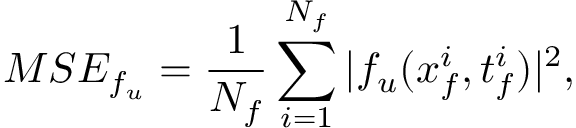<formula> <loc_0><loc_0><loc_500><loc_500>M S E _ { f _ { u } } = \frac { 1 } { N _ { f } } \sum _ { i = 1 } ^ { N _ { f } } | f _ { u } ( x _ { f } ^ { i } , t _ { f } ^ { i } ) | ^ { 2 } ,</formula> 